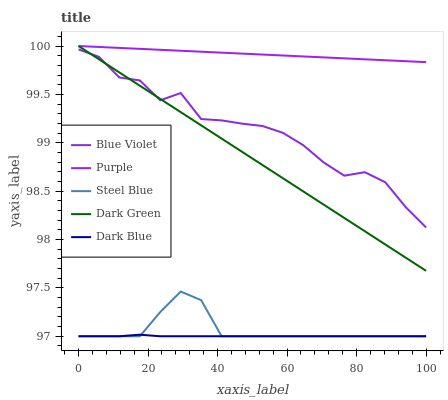Does Dark Blue have the minimum area under the curve?
Answer yes or no. Yes. Does Purple have the maximum area under the curve?
Answer yes or no. Yes. Does Steel Blue have the minimum area under the curve?
Answer yes or no. No. Does Steel Blue have the maximum area under the curve?
Answer yes or no. No. Is Purple the smoothest?
Answer yes or no. Yes. Is Blue Violet the roughest?
Answer yes or no. Yes. Is Dark Blue the smoothest?
Answer yes or no. No. Is Dark Blue the roughest?
Answer yes or no. No. Does Dark Blue have the lowest value?
Answer yes or no. Yes. Does Blue Violet have the lowest value?
Answer yes or no. No. Does Dark Green have the highest value?
Answer yes or no. Yes. Does Steel Blue have the highest value?
Answer yes or no. No. Is Dark Blue less than Blue Violet?
Answer yes or no. Yes. Is Blue Violet greater than Dark Blue?
Answer yes or no. Yes. Does Dark Green intersect Purple?
Answer yes or no. Yes. Is Dark Green less than Purple?
Answer yes or no. No. Is Dark Green greater than Purple?
Answer yes or no. No. Does Dark Blue intersect Blue Violet?
Answer yes or no. No. 